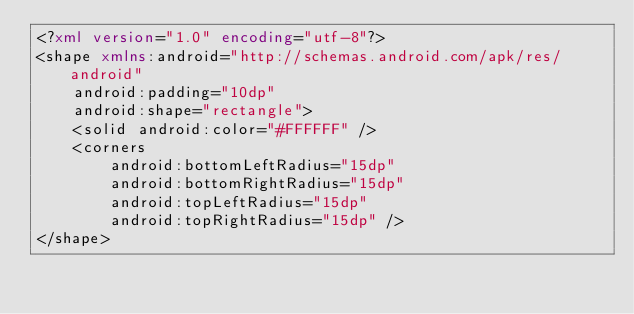<code> <loc_0><loc_0><loc_500><loc_500><_XML_><?xml version="1.0" encoding="utf-8"?>
<shape xmlns:android="http://schemas.android.com/apk/res/android"
    android:padding="10dp"
    android:shape="rectangle">
    <solid android:color="#FFFFFF" />
    <corners
        android:bottomLeftRadius="15dp"
        android:bottomRightRadius="15dp"
        android:topLeftRadius="15dp"
        android:topRightRadius="15dp" />
</shape></code> 